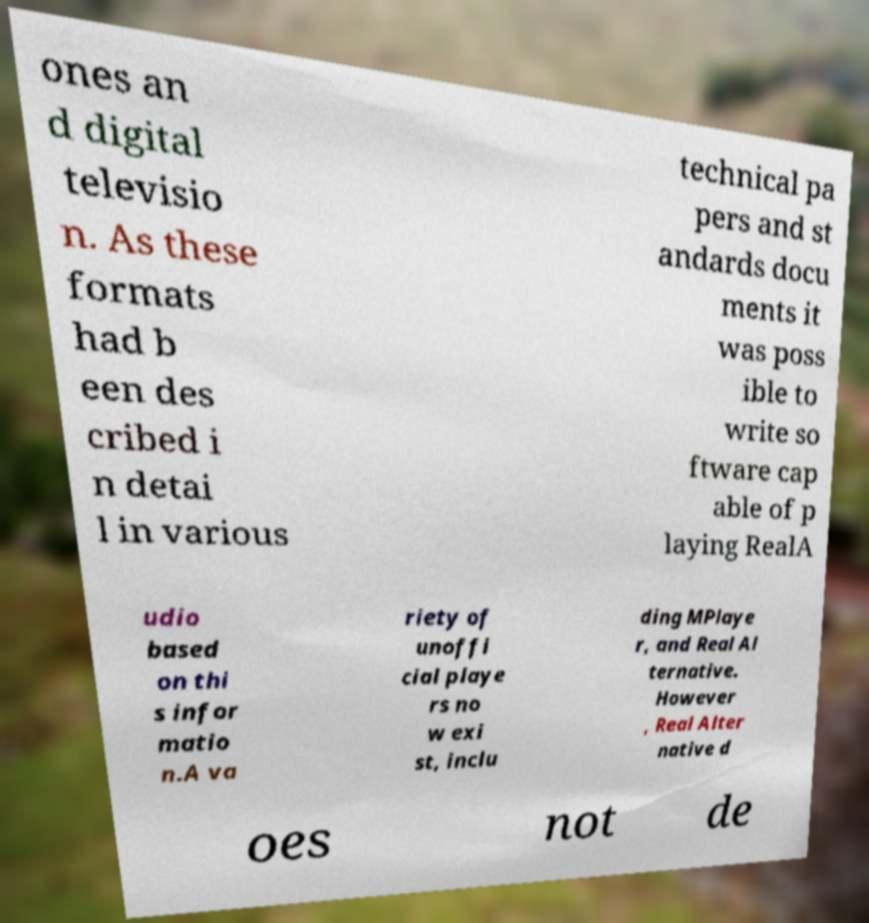Can you read and provide the text displayed in the image?This photo seems to have some interesting text. Can you extract and type it out for me? ones an d digital televisio n. As these formats had b een des cribed i n detai l in various technical pa pers and st andards docu ments it was poss ible to write so ftware cap able of p laying RealA udio based on thi s infor matio n.A va riety of unoffi cial playe rs no w exi st, inclu ding MPlaye r, and Real Al ternative. However , Real Alter native d oes not de 